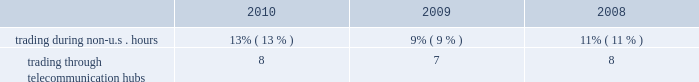Kendal vroman , 39 mr .
Vroman has served as our managing director , commodity products , otc services & information products since february 2010 .
Mr .
Vroman previously served as managing director and chief corporate development officer from 2008 to 2010 .
Mr .
Vroman joined us in 2001 and since then has held positions of increasing responsibility , including most recently as managing director , corporate development and managing director , information and technology services .
Scot e .
Warren , 47 mr .
Warren has served as our managing director , equity index products and index services since february 2010 .
Mr .
Warren previously served as our managing director , equity products since joining us in 2007 .
Prior to that , mr .
Warren worked for goldman sachs as its president , manager trading and business analysis team .
Prior to goldman sachs , mr .
Warren managed equity and option execution and clearing businesses for abn amro in chicago and was a senior consultant for arthur andersen & co .
For financial services firms .
Financial information about geographic areas due to the nature of its business , cme group does not track revenues based upon geographic location .
We do , however , track trading volume generated outside of traditional u.s .
Trading hours and through our international telecommunication hubs .
Our customers can directly access our exchanges throughout the world .
The table shows the percentage of our total trading volume on our globex electronic trading platform generated during non-u.s .
Hours and through our international hubs. .
Available information our web site is www.cmegroup.com .
Information made available on our web site does not constitute part of this document .
We make available on our web site our annual reports on form 10-k , quarterly reports on form 10-q , current reports on form 8-k and amendments to those reports as soon as reasonably practicable after we electronically file or furnish such materials to the sec .
Our corporate governance materials , including our corporate governance principles , director conflict of interest policy , board of directors code of ethics , categorical independence standards , employee code of conduct and the charters for all the standing committees of our board , may also be found on our web site .
Copies of these materials are also available to shareholders free of charge upon written request to shareholder relations and member services , attention ms .
Beth hausoul , cme group inc. , 20 south wacker drive , chicago , illinois 60606. .
What is the increase percentage of trading during the us hours between 2008 and 2009? 
Rationale: its the difference between the variation of the total percentage of trading hours ( 100% ) and the trading in non us hours ( 9% ) in 2009 and the variation of the total percentage of trading hours ( 100% ) and the trading in non us hours ( 11% ) in 2008 .
Computations: ((100 - 9) - (100 - 11))
Answer: 2.0. 